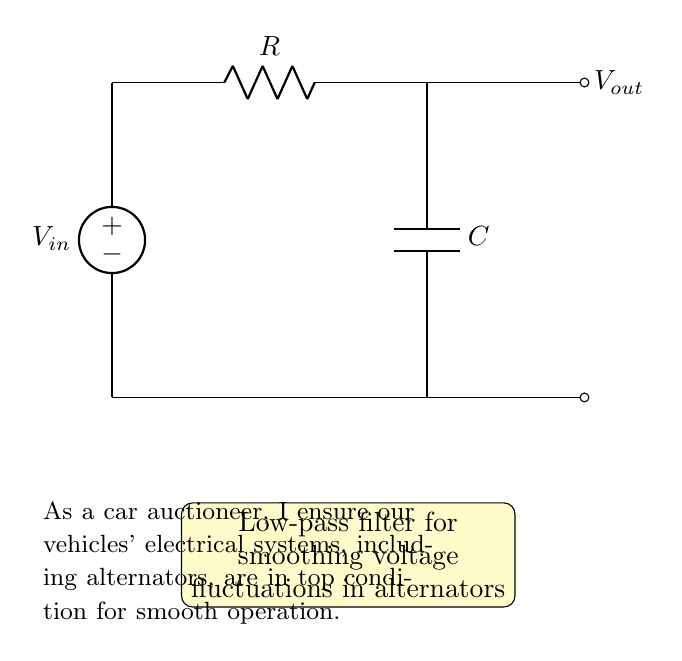What is the input voltage source label? The input voltage source in the circuit is labeled as V_in, indicating the voltage supplied to the circuit.
Answer: V_in What is the value of the resistor in the circuit? The resistor is labeled as R, which indicates it is an essential passive component in the circuit but does not specify an exact value; it is a general representation of a resistor.
Answer: R What type of filter is represented by this circuit? The overall function of the circuit is to act as a low-pass filter, which is indicated by the configuration of the resistor and capacitor that smooths out voltage fluctuations.
Answer: Low-pass filter What components are used in this low-pass filter? The circuit diagram includes two components: a resistor (R) and a capacitor (C), which together form the low-pass filter.
Answer: Resistor and Capacitor How does a low-pass filter behave with high-frequency signals? A low-pass filter allows low-frequency signals to pass while attenuating high-frequency signals, which means that high-frequency fluctuations will be reduced in the output voltage.
Answer: Attenuates high-frequency signals What is the output voltage labeled in the circuit? The output voltage is denoted as V_out, which represents the voltage across the output of the filter after processing the input voltage.
Answer: V_out What is the purpose of the capacitor in this circuit? The capacitor stores and releases energy, smoothing out voltage fluctuations by charging and discharging in response to changes in voltage over time, contributing to the filtering effect.
Answer: Smoothing voltage fluctuations 